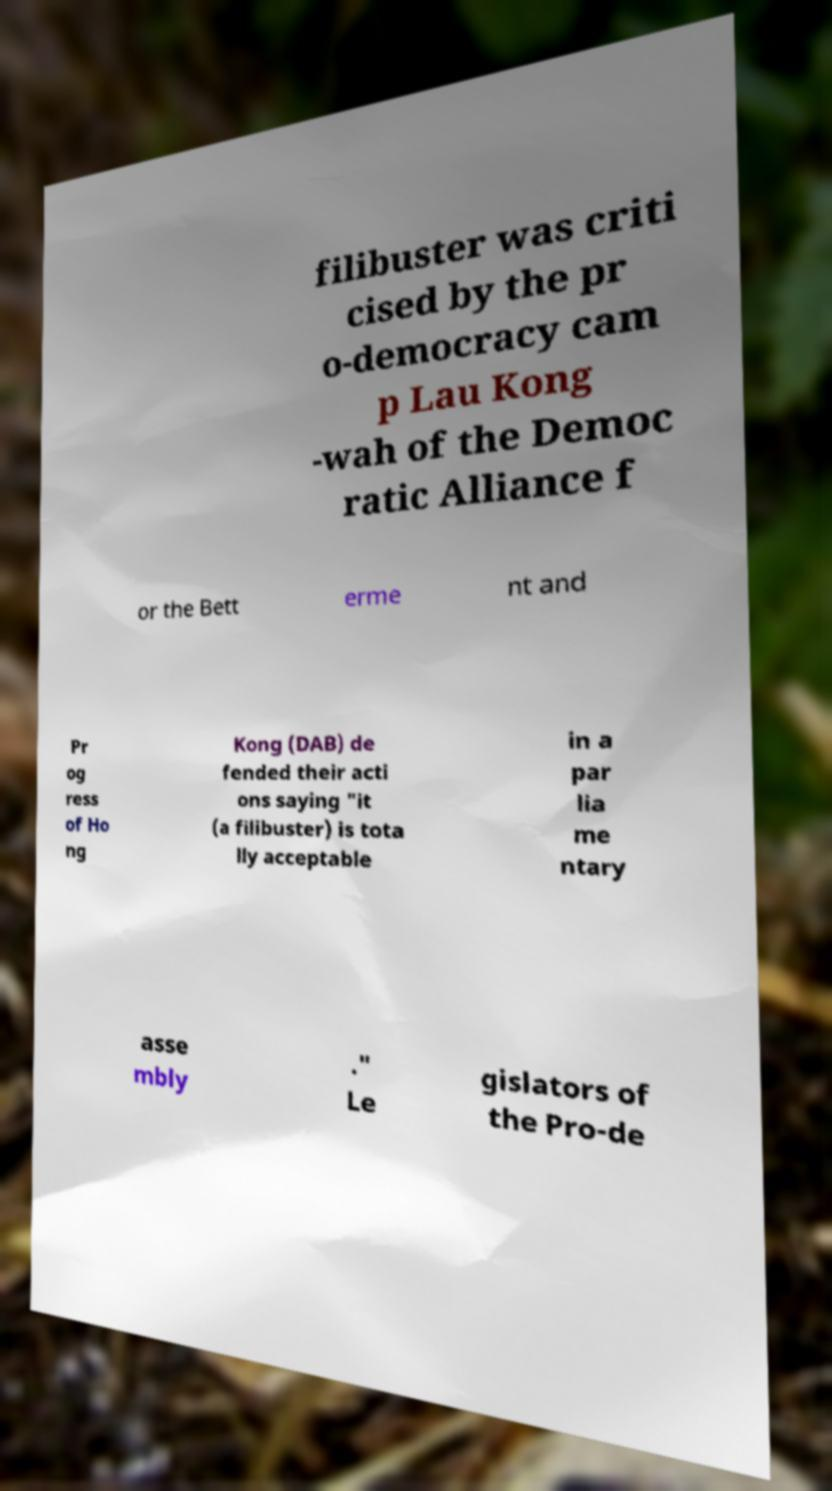I need the written content from this picture converted into text. Can you do that? filibuster was criti cised by the pr o-democracy cam p Lau Kong -wah of the Democ ratic Alliance f or the Bett erme nt and Pr og ress of Ho ng Kong (DAB) de fended their acti ons saying "it (a filibuster) is tota lly acceptable in a par lia me ntary asse mbly ." Le gislators of the Pro-de 